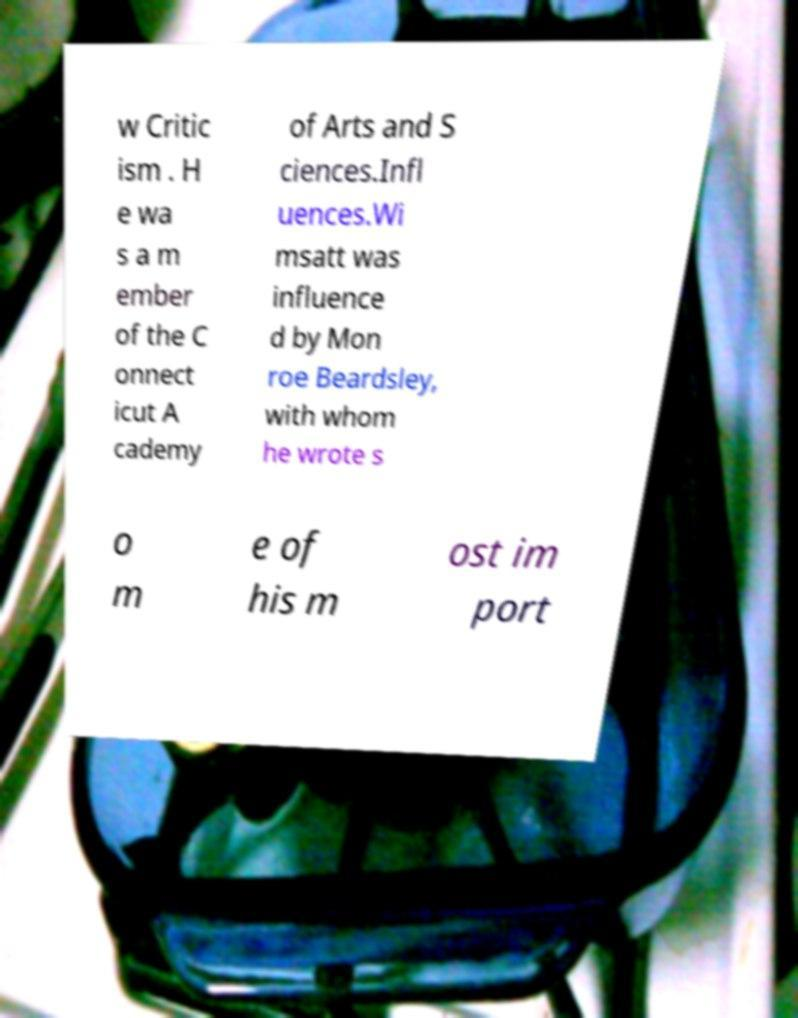For documentation purposes, I need the text within this image transcribed. Could you provide that? w Critic ism . H e wa s a m ember of the C onnect icut A cademy of Arts and S ciences.Infl uences.Wi msatt was influence d by Mon roe Beardsley, with whom he wrote s o m e of his m ost im port 